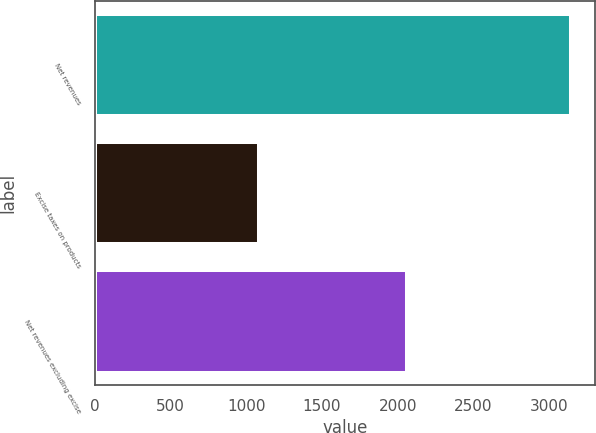Convert chart. <chart><loc_0><loc_0><loc_500><loc_500><bar_chart><fcel>Net revenues<fcel>Excise taxes on products<fcel>Net revenues excluding excise<nl><fcel>3145<fcel>1082<fcel>2063<nl></chart> 